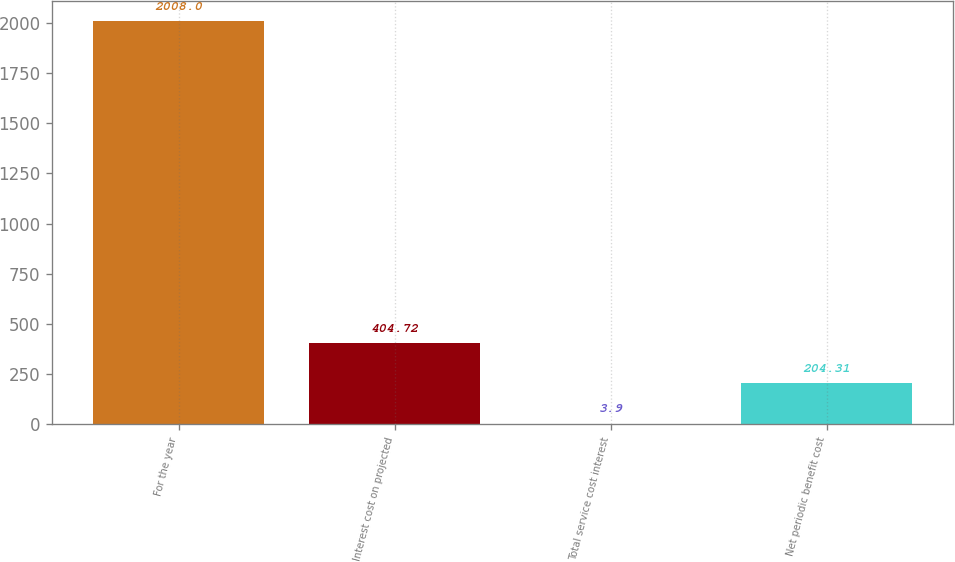Convert chart to OTSL. <chart><loc_0><loc_0><loc_500><loc_500><bar_chart><fcel>For the year<fcel>Interest cost on projected<fcel>Total service cost interest<fcel>Net periodic benefit cost<nl><fcel>2008<fcel>404.72<fcel>3.9<fcel>204.31<nl></chart> 